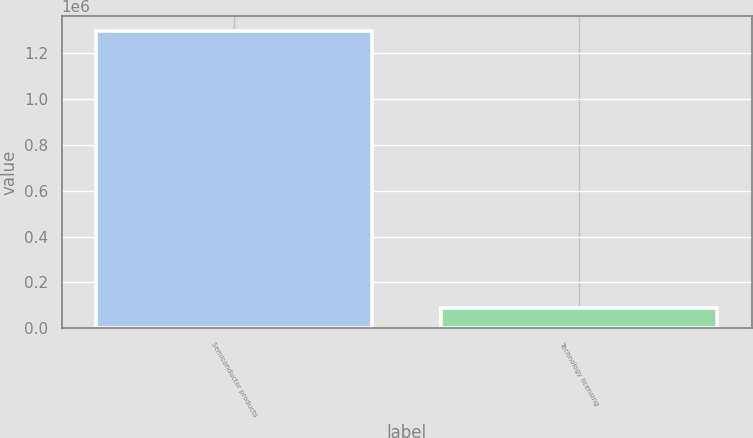Convert chart to OTSL. <chart><loc_0><loc_0><loc_500><loc_500><bar_chart><fcel>Semiconductor products<fcel>Technology licensing<nl><fcel>1.29618e+06<fcel>87001<nl></chart> 